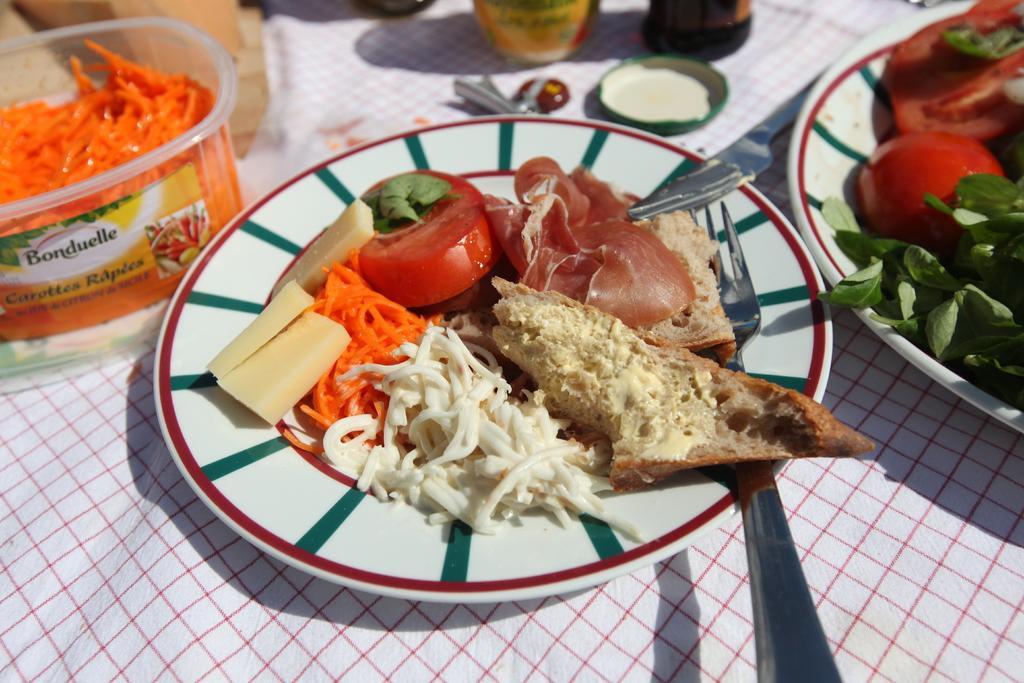Describe this image in one or two sentences. At the bottom of the image there is a table with a table cloth, two jars, a lid and a box with grated carrot and two plates with food items on it. On the right side of the image there is a plate with tomato slices and green leaves on it. In the middle of the image there is a plate with a fork, a meat slice, a toast, cheese, grated carrots and tomato slices on it. 